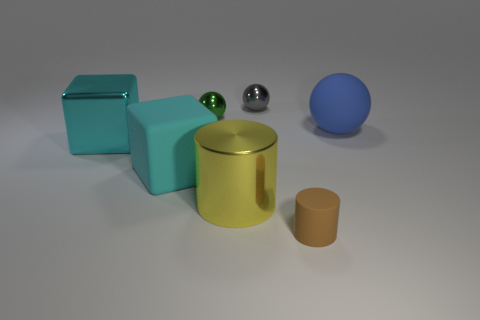Subtract all small balls. How many balls are left? 1 Add 2 metal blocks. How many objects exist? 9 Subtract 1 balls. How many balls are left? 2 Subtract all cylinders. How many objects are left? 5 Subtract all cyan blocks. Subtract all small purple metal spheres. How many objects are left? 5 Add 4 cylinders. How many cylinders are left? 6 Add 2 purple matte objects. How many purple matte objects exist? 2 Subtract 1 yellow cylinders. How many objects are left? 6 